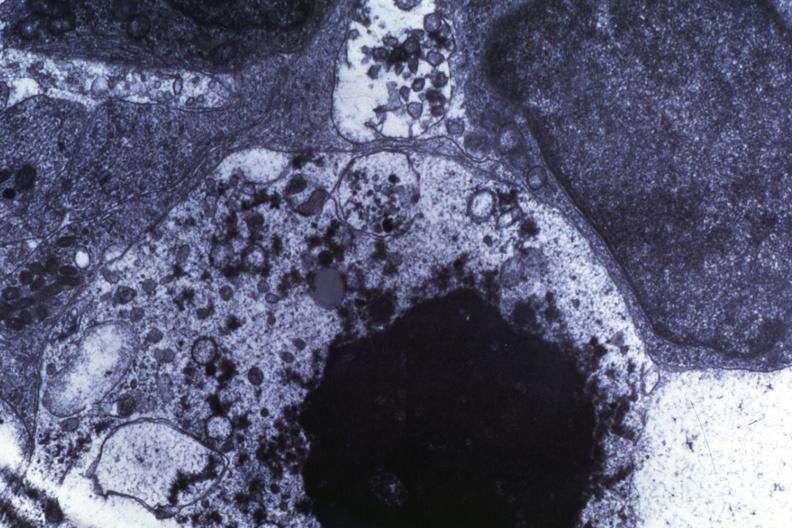does rheumatoid arthritis show necrosis dr garcia tumors 67?
Answer the question using a single word or phrase. No 